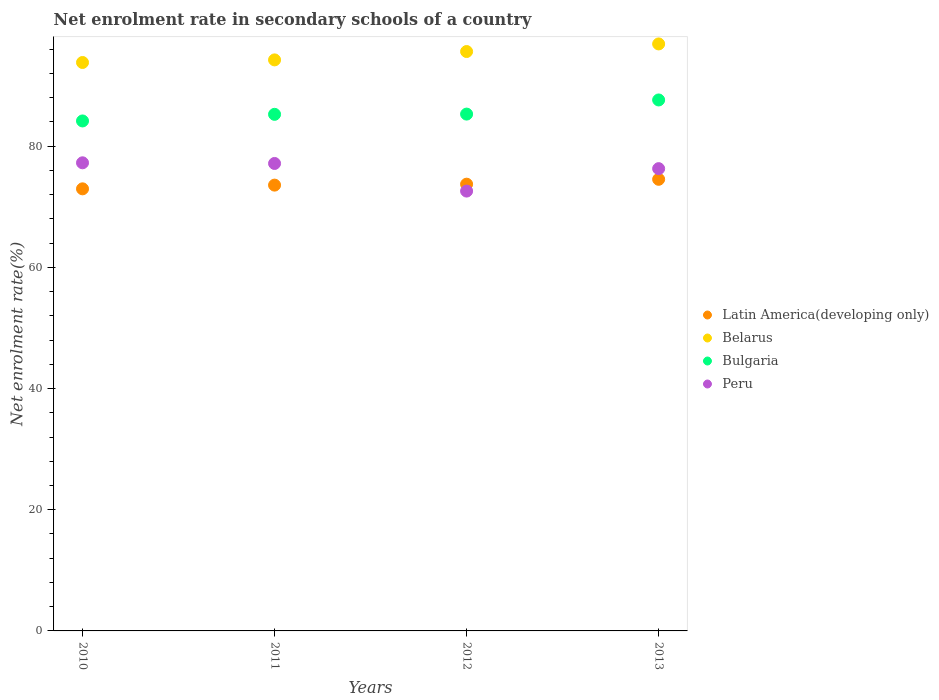How many different coloured dotlines are there?
Make the answer very short. 4. What is the net enrolment rate in secondary schools in Latin America(developing only) in 2012?
Give a very brief answer. 73.72. Across all years, what is the maximum net enrolment rate in secondary schools in Belarus?
Offer a very short reply. 96.86. Across all years, what is the minimum net enrolment rate in secondary schools in Bulgaria?
Keep it short and to the point. 84.15. In which year was the net enrolment rate in secondary schools in Bulgaria maximum?
Offer a very short reply. 2013. In which year was the net enrolment rate in secondary schools in Peru minimum?
Your answer should be compact. 2012. What is the total net enrolment rate in secondary schools in Latin America(developing only) in the graph?
Offer a terse response. 294.76. What is the difference between the net enrolment rate in secondary schools in Bulgaria in 2010 and that in 2013?
Your answer should be compact. -3.46. What is the difference between the net enrolment rate in secondary schools in Bulgaria in 2013 and the net enrolment rate in secondary schools in Latin America(developing only) in 2012?
Offer a very short reply. 13.9. What is the average net enrolment rate in secondary schools in Peru per year?
Your answer should be compact. 75.81. In the year 2012, what is the difference between the net enrolment rate in secondary schools in Belarus and net enrolment rate in secondary schools in Latin America(developing only)?
Provide a succinct answer. 21.89. In how many years, is the net enrolment rate in secondary schools in Peru greater than 44 %?
Make the answer very short. 4. What is the ratio of the net enrolment rate in secondary schools in Latin America(developing only) in 2011 to that in 2013?
Provide a short and direct response. 0.99. Is the difference between the net enrolment rate in secondary schools in Belarus in 2010 and 2012 greater than the difference between the net enrolment rate in secondary schools in Latin America(developing only) in 2010 and 2012?
Provide a succinct answer. No. What is the difference between the highest and the second highest net enrolment rate in secondary schools in Belarus?
Ensure brevity in your answer.  1.25. What is the difference between the highest and the lowest net enrolment rate in secondary schools in Latin America(developing only)?
Provide a succinct answer. 1.57. Is the sum of the net enrolment rate in secondary schools in Belarus in 2010 and 2013 greater than the maximum net enrolment rate in secondary schools in Bulgaria across all years?
Your answer should be compact. Yes. Is it the case that in every year, the sum of the net enrolment rate in secondary schools in Belarus and net enrolment rate in secondary schools in Bulgaria  is greater than the sum of net enrolment rate in secondary schools in Latin America(developing only) and net enrolment rate in secondary schools in Peru?
Your answer should be very brief. Yes. Is it the case that in every year, the sum of the net enrolment rate in secondary schools in Belarus and net enrolment rate in secondary schools in Peru  is greater than the net enrolment rate in secondary schools in Latin America(developing only)?
Offer a very short reply. Yes. Does the net enrolment rate in secondary schools in Bulgaria monotonically increase over the years?
Give a very brief answer. Yes. Is the net enrolment rate in secondary schools in Latin America(developing only) strictly greater than the net enrolment rate in secondary schools in Belarus over the years?
Offer a very short reply. No. How many dotlines are there?
Ensure brevity in your answer.  4. Does the graph contain any zero values?
Give a very brief answer. No. Does the graph contain grids?
Provide a short and direct response. No. Where does the legend appear in the graph?
Offer a terse response. Center right. How many legend labels are there?
Offer a terse response. 4. What is the title of the graph?
Offer a very short reply. Net enrolment rate in secondary schools of a country. What is the label or title of the Y-axis?
Offer a terse response. Net enrolment rate(%). What is the Net enrolment rate(%) of Latin America(developing only) in 2010?
Keep it short and to the point. 72.95. What is the Net enrolment rate(%) in Belarus in 2010?
Offer a very short reply. 93.8. What is the Net enrolment rate(%) in Bulgaria in 2010?
Provide a succinct answer. 84.15. What is the Net enrolment rate(%) of Peru in 2010?
Provide a short and direct response. 77.25. What is the Net enrolment rate(%) of Latin America(developing only) in 2011?
Make the answer very short. 73.56. What is the Net enrolment rate(%) of Belarus in 2011?
Provide a succinct answer. 94.23. What is the Net enrolment rate(%) of Bulgaria in 2011?
Ensure brevity in your answer.  85.25. What is the Net enrolment rate(%) in Peru in 2011?
Ensure brevity in your answer.  77.14. What is the Net enrolment rate(%) of Latin America(developing only) in 2012?
Offer a terse response. 73.72. What is the Net enrolment rate(%) in Belarus in 2012?
Offer a very short reply. 95.61. What is the Net enrolment rate(%) in Bulgaria in 2012?
Give a very brief answer. 85.29. What is the Net enrolment rate(%) of Peru in 2012?
Offer a terse response. 72.58. What is the Net enrolment rate(%) in Latin America(developing only) in 2013?
Your answer should be very brief. 74.52. What is the Net enrolment rate(%) of Belarus in 2013?
Keep it short and to the point. 96.86. What is the Net enrolment rate(%) in Bulgaria in 2013?
Offer a very short reply. 87.62. What is the Net enrolment rate(%) in Peru in 2013?
Offer a very short reply. 76.28. Across all years, what is the maximum Net enrolment rate(%) of Latin America(developing only)?
Give a very brief answer. 74.52. Across all years, what is the maximum Net enrolment rate(%) in Belarus?
Your answer should be compact. 96.86. Across all years, what is the maximum Net enrolment rate(%) in Bulgaria?
Offer a very short reply. 87.62. Across all years, what is the maximum Net enrolment rate(%) of Peru?
Your answer should be compact. 77.25. Across all years, what is the minimum Net enrolment rate(%) in Latin America(developing only)?
Ensure brevity in your answer.  72.95. Across all years, what is the minimum Net enrolment rate(%) of Belarus?
Make the answer very short. 93.8. Across all years, what is the minimum Net enrolment rate(%) of Bulgaria?
Offer a terse response. 84.15. Across all years, what is the minimum Net enrolment rate(%) in Peru?
Offer a terse response. 72.58. What is the total Net enrolment rate(%) in Latin America(developing only) in the graph?
Your answer should be compact. 294.76. What is the total Net enrolment rate(%) of Belarus in the graph?
Your response must be concise. 380.5. What is the total Net enrolment rate(%) of Bulgaria in the graph?
Provide a short and direct response. 342.3. What is the total Net enrolment rate(%) of Peru in the graph?
Your answer should be very brief. 303.25. What is the difference between the Net enrolment rate(%) in Latin America(developing only) in 2010 and that in 2011?
Keep it short and to the point. -0.61. What is the difference between the Net enrolment rate(%) in Belarus in 2010 and that in 2011?
Offer a very short reply. -0.43. What is the difference between the Net enrolment rate(%) of Bulgaria in 2010 and that in 2011?
Offer a terse response. -1.09. What is the difference between the Net enrolment rate(%) of Peru in 2010 and that in 2011?
Your answer should be very brief. 0.11. What is the difference between the Net enrolment rate(%) in Latin America(developing only) in 2010 and that in 2012?
Make the answer very short. -0.77. What is the difference between the Net enrolment rate(%) in Belarus in 2010 and that in 2012?
Make the answer very short. -1.81. What is the difference between the Net enrolment rate(%) in Bulgaria in 2010 and that in 2012?
Your answer should be very brief. -1.13. What is the difference between the Net enrolment rate(%) in Peru in 2010 and that in 2012?
Your response must be concise. 4.67. What is the difference between the Net enrolment rate(%) in Latin America(developing only) in 2010 and that in 2013?
Offer a terse response. -1.57. What is the difference between the Net enrolment rate(%) of Belarus in 2010 and that in 2013?
Your response must be concise. -3.06. What is the difference between the Net enrolment rate(%) in Bulgaria in 2010 and that in 2013?
Offer a terse response. -3.46. What is the difference between the Net enrolment rate(%) in Peru in 2010 and that in 2013?
Offer a very short reply. 0.96. What is the difference between the Net enrolment rate(%) of Latin America(developing only) in 2011 and that in 2012?
Provide a short and direct response. -0.16. What is the difference between the Net enrolment rate(%) of Belarus in 2011 and that in 2012?
Your answer should be compact. -1.38. What is the difference between the Net enrolment rate(%) of Bulgaria in 2011 and that in 2012?
Provide a short and direct response. -0.04. What is the difference between the Net enrolment rate(%) of Peru in 2011 and that in 2012?
Offer a very short reply. 4.56. What is the difference between the Net enrolment rate(%) in Latin America(developing only) in 2011 and that in 2013?
Offer a very short reply. -0.96. What is the difference between the Net enrolment rate(%) of Belarus in 2011 and that in 2013?
Offer a terse response. -2.63. What is the difference between the Net enrolment rate(%) in Bulgaria in 2011 and that in 2013?
Provide a succinct answer. -2.37. What is the difference between the Net enrolment rate(%) in Peru in 2011 and that in 2013?
Your answer should be very brief. 0.86. What is the difference between the Net enrolment rate(%) in Latin America(developing only) in 2012 and that in 2013?
Provide a short and direct response. -0.8. What is the difference between the Net enrolment rate(%) in Belarus in 2012 and that in 2013?
Your answer should be compact. -1.25. What is the difference between the Net enrolment rate(%) of Bulgaria in 2012 and that in 2013?
Provide a succinct answer. -2.33. What is the difference between the Net enrolment rate(%) of Peru in 2012 and that in 2013?
Your answer should be compact. -3.7. What is the difference between the Net enrolment rate(%) of Latin America(developing only) in 2010 and the Net enrolment rate(%) of Belarus in 2011?
Your answer should be compact. -21.28. What is the difference between the Net enrolment rate(%) of Latin America(developing only) in 2010 and the Net enrolment rate(%) of Bulgaria in 2011?
Your answer should be compact. -12.29. What is the difference between the Net enrolment rate(%) in Latin America(developing only) in 2010 and the Net enrolment rate(%) in Peru in 2011?
Provide a short and direct response. -4.19. What is the difference between the Net enrolment rate(%) of Belarus in 2010 and the Net enrolment rate(%) of Bulgaria in 2011?
Offer a terse response. 8.55. What is the difference between the Net enrolment rate(%) in Belarus in 2010 and the Net enrolment rate(%) in Peru in 2011?
Give a very brief answer. 16.66. What is the difference between the Net enrolment rate(%) in Bulgaria in 2010 and the Net enrolment rate(%) in Peru in 2011?
Provide a succinct answer. 7.02. What is the difference between the Net enrolment rate(%) in Latin America(developing only) in 2010 and the Net enrolment rate(%) in Belarus in 2012?
Your answer should be very brief. -22.66. What is the difference between the Net enrolment rate(%) of Latin America(developing only) in 2010 and the Net enrolment rate(%) of Bulgaria in 2012?
Keep it short and to the point. -12.33. What is the difference between the Net enrolment rate(%) in Latin America(developing only) in 2010 and the Net enrolment rate(%) in Peru in 2012?
Keep it short and to the point. 0.37. What is the difference between the Net enrolment rate(%) of Belarus in 2010 and the Net enrolment rate(%) of Bulgaria in 2012?
Offer a very short reply. 8.51. What is the difference between the Net enrolment rate(%) of Belarus in 2010 and the Net enrolment rate(%) of Peru in 2012?
Your response must be concise. 21.22. What is the difference between the Net enrolment rate(%) of Bulgaria in 2010 and the Net enrolment rate(%) of Peru in 2012?
Your answer should be compact. 11.57. What is the difference between the Net enrolment rate(%) in Latin America(developing only) in 2010 and the Net enrolment rate(%) in Belarus in 2013?
Make the answer very short. -23.91. What is the difference between the Net enrolment rate(%) of Latin America(developing only) in 2010 and the Net enrolment rate(%) of Bulgaria in 2013?
Offer a terse response. -14.67. What is the difference between the Net enrolment rate(%) in Latin America(developing only) in 2010 and the Net enrolment rate(%) in Peru in 2013?
Provide a succinct answer. -3.33. What is the difference between the Net enrolment rate(%) in Belarus in 2010 and the Net enrolment rate(%) in Bulgaria in 2013?
Your answer should be very brief. 6.18. What is the difference between the Net enrolment rate(%) of Belarus in 2010 and the Net enrolment rate(%) of Peru in 2013?
Make the answer very short. 17.52. What is the difference between the Net enrolment rate(%) of Bulgaria in 2010 and the Net enrolment rate(%) of Peru in 2013?
Give a very brief answer. 7.87. What is the difference between the Net enrolment rate(%) in Latin America(developing only) in 2011 and the Net enrolment rate(%) in Belarus in 2012?
Provide a short and direct response. -22.04. What is the difference between the Net enrolment rate(%) in Latin America(developing only) in 2011 and the Net enrolment rate(%) in Bulgaria in 2012?
Your answer should be very brief. -11.72. What is the difference between the Net enrolment rate(%) of Latin America(developing only) in 2011 and the Net enrolment rate(%) of Peru in 2012?
Keep it short and to the point. 0.98. What is the difference between the Net enrolment rate(%) in Belarus in 2011 and the Net enrolment rate(%) in Bulgaria in 2012?
Offer a very short reply. 8.94. What is the difference between the Net enrolment rate(%) of Belarus in 2011 and the Net enrolment rate(%) of Peru in 2012?
Provide a short and direct response. 21.65. What is the difference between the Net enrolment rate(%) of Bulgaria in 2011 and the Net enrolment rate(%) of Peru in 2012?
Give a very brief answer. 12.66. What is the difference between the Net enrolment rate(%) of Latin America(developing only) in 2011 and the Net enrolment rate(%) of Belarus in 2013?
Provide a short and direct response. -23.3. What is the difference between the Net enrolment rate(%) in Latin America(developing only) in 2011 and the Net enrolment rate(%) in Bulgaria in 2013?
Provide a short and direct response. -14.05. What is the difference between the Net enrolment rate(%) in Latin America(developing only) in 2011 and the Net enrolment rate(%) in Peru in 2013?
Keep it short and to the point. -2.72. What is the difference between the Net enrolment rate(%) in Belarus in 2011 and the Net enrolment rate(%) in Bulgaria in 2013?
Make the answer very short. 6.61. What is the difference between the Net enrolment rate(%) in Belarus in 2011 and the Net enrolment rate(%) in Peru in 2013?
Make the answer very short. 17.95. What is the difference between the Net enrolment rate(%) in Bulgaria in 2011 and the Net enrolment rate(%) in Peru in 2013?
Your answer should be very brief. 8.96. What is the difference between the Net enrolment rate(%) in Latin America(developing only) in 2012 and the Net enrolment rate(%) in Belarus in 2013?
Offer a terse response. -23.14. What is the difference between the Net enrolment rate(%) of Latin America(developing only) in 2012 and the Net enrolment rate(%) of Bulgaria in 2013?
Your answer should be compact. -13.9. What is the difference between the Net enrolment rate(%) in Latin America(developing only) in 2012 and the Net enrolment rate(%) in Peru in 2013?
Keep it short and to the point. -2.56. What is the difference between the Net enrolment rate(%) in Belarus in 2012 and the Net enrolment rate(%) in Bulgaria in 2013?
Your answer should be compact. 7.99. What is the difference between the Net enrolment rate(%) in Belarus in 2012 and the Net enrolment rate(%) in Peru in 2013?
Provide a short and direct response. 19.33. What is the difference between the Net enrolment rate(%) of Bulgaria in 2012 and the Net enrolment rate(%) of Peru in 2013?
Your answer should be very brief. 9. What is the average Net enrolment rate(%) of Latin America(developing only) per year?
Ensure brevity in your answer.  73.69. What is the average Net enrolment rate(%) of Belarus per year?
Ensure brevity in your answer.  95.13. What is the average Net enrolment rate(%) in Bulgaria per year?
Ensure brevity in your answer.  85.58. What is the average Net enrolment rate(%) in Peru per year?
Ensure brevity in your answer.  75.81. In the year 2010, what is the difference between the Net enrolment rate(%) in Latin America(developing only) and Net enrolment rate(%) in Belarus?
Your response must be concise. -20.85. In the year 2010, what is the difference between the Net enrolment rate(%) of Latin America(developing only) and Net enrolment rate(%) of Bulgaria?
Provide a succinct answer. -11.2. In the year 2010, what is the difference between the Net enrolment rate(%) in Latin America(developing only) and Net enrolment rate(%) in Peru?
Offer a terse response. -4.3. In the year 2010, what is the difference between the Net enrolment rate(%) in Belarus and Net enrolment rate(%) in Bulgaria?
Offer a terse response. 9.65. In the year 2010, what is the difference between the Net enrolment rate(%) of Belarus and Net enrolment rate(%) of Peru?
Keep it short and to the point. 16.55. In the year 2010, what is the difference between the Net enrolment rate(%) of Bulgaria and Net enrolment rate(%) of Peru?
Make the answer very short. 6.91. In the year 2011, what is the difference between the Net enrolment rate(%) in Latin America(developing only) and Net enrolment rate(%) in Belarus?
Provide a short and direct response. -20.66. In the year 2011, what is the difference between the Net enrolment rate(%) of Latin America(developing only) and Net enrolment rate(%) of Bulgaria?
Offer a terse response. -11.68. In the year 2011, what is the difference between the Net enrolment rate(%) in Latin America(developing only) and Net enrolment rate(%) in Peru?
Keep it short and to the point. -3.57. In the year 2011, what is the difference between the Net enrolment rate(%) in Belarus and Net enrolment rate(%) in Bulgaria?
Provide a short and direct response. 8.98. In the year 2011, what is the difference between the Net enrolment rate(%) of Belarus and Net enrolment rate(%) of Peru?
Your answer should be compact. 17.09. In the year 2011, what is the difference between the Net enrolment rate(%) of Bulgaria and Net enrolment rate(%) of Peru?
Make the answer very short. 8.11. In the year 2012, what is the difference between the Net enrolment rate(%) in Latin America(developing only) and Net enrolment rate(%) in Belarus?
Your answer should be very brief. -21.89. In the year 2012, what is the difference between the Net enrolment rate(%) of Latin America(developing only) and Net enrolment rate(%) of Bulgaria?
Make the answer very short. -11.57. In the year 2012, what is the difference between the Net enrolment rate(%) of Latin America(developing only) and Net enrolment rate(%) of Peru?
Your response must be concise. 1.14. In the year 2012, what is the difference between the Net enrolment rate(%) of Belarus and Net enrolment rate(%) of Bulgaria?
Provide a short and direct response. 10.32. In the year 2012, what is the difference between the Net enrolment rate(%) of Belarus and Net enrolment rate(%) of Peru?
Provide a succinct answer. 23.03. In the year 2012, what is the difference between the Net enrolment rate(%) in Bulgaria and Net enrolment rate(%) in Peru?
Offer a very short reply. 12.7. In the year 2013, what is the difference between the Net enrolment rate(%) in Latin America(developing only) and Net enrolment rate(%) in Belarus?
Ensure brevity in your answer.  -22.34. In the year 2013, what is the difference between the Net enrolment rate(%) in Latin America(developing only) and Net enrolment rate(%) in Bulgaria?
Provide a succinct answer. -13.09. In the year 2013, what is the difference between the Net enrolment rate(%) in Latin America(developing only) and Net enrolment rate(%) in Peru?
Ensure brevity in your answer.  -1.76. In the year 2013, what is the difference between the Net enrolment rate(%) in Belarus and Net enrolment rate(%) in Bulgaria?
Offer a very short reply. 9.25. In the year 2013, what is the difference between the Net enrolment rate(%) in Belarus and Net enrolment rate(%) in Peru?
Give a very brief answer. 20.58. In the year 2013, what is the difference between the Net enrolment rate(%) in Bulgaria and Net enrolment rate(%) in Peru?
Offer a very short reply. 11.34. What is the ratio of the Net enrolment rate(%) in Latin America(developing only) in 2010 to that in 2011?
Give a very brief answer. 0.99. What is the ratio of the Net enrolment rate(%) in Bulgaria in 2010 to that in 2011?
Ensure brevity in your answer.  0.99. What is the ratio of the Net enrolment rate(%) in Peru in 2010 to that in 2011?
Give a very brief answer. 1. What is the ratio of the Net enrolment rate(%) in Belarus in 2010 to that in 2012?
Provide a succinct answer. 0.98. What is the ratio of the Net enrolment rate(%) in Bulgaria in 2010 to that in 2012?
Ensure brevity in your answer.  0.99. What is the ratio of the Net enrolment rate(%) in Peru in 2010 to that in 2012?
Offer a very short reply. 1.06. What is the ratio of the Net enrolment rate(%) in Latin America(developing only) in 2010 to that in 2013?
Your response must be concise. 0.98. What is the ratio of the Net enrolment rate(%) in Belarus in 2010 to that in 2013?
Provide a short and direct response. 0.97. What is the ratio of the Net enrolment rate(%) of Bulgaria in 2010 to that in 2013?
Provide a succinct answer. 0.96. What is the ratio of the Net enrolment rate(%) in Peru in 2010 to that in 2013?
Keep it short and to the point. 1.01. What is the ratio of the Net enrolment rate(%) in Latin America(developing only) in 2011 to that in 2012?
Keep it short and to the point. 1. What is the ratio of the Net enrolment rate(%) in Belarus in 2011 to that in 2012?
Your answer should be very brief. 0.99. What is the ratio of the Net enrolment rate(%) of Bulgaria in 2011 to that in 2012?
Your response must be concise. 1. What is the ratio of the Net enrolment rate(%) of Peru in 2011 to that in 2012?
Your response must be concise. 1.06. What is the ratio of the Net enrolment rate(%) in Latin America(developing only) in 2011 to that in 2013?
Provide a short and direct response. 0.99. What is the ratio of the Net enrolment rate(%) in Belarus in 2011 to that in 2013?
Ensure brevity in your answer.  0.97. What is the ratio of the Net enrolment rate(%) of Bulgaria in 2011 to that in 2013?
Your response must be concise. 0.97. What is the ratio of the Net enrolment rate(%) in Peru in 2011 to that in 2013?
Keep it short and to the point. 1.01. What is the ratio of the Net enrolment rate(%) in Latin America(developing only) in 2012 to that in 2013?
Give a very brief answer. 0.99. What is the ratio of the Net enrolment rate(%) of Belarus in 2012 to that in 2013?
Your response must be concise. 0.99. What is the ratio of the Net enrolment rate(%) of Bulgaria in 2012 to that in 2013?
Offer a terse response. 0.97. What is the ratio of the Net enrolment rate(%) in Peru in 2012 to that in 2013?
Provide a succinct answer. 0.95. What is the difference between the highest and the second highest Net enrolment rate(%) in Latin America(developing only)?
Keep it short and to the point. 0.8. What is the difference between the highest and the second highest Net enrolment rate(%) in Belarus?
Offer a terse response. 1.25. What is the difference between the highest and the second highest Net enrolment rate(%) in Bulgaria?
Your response must be concise. 2.33. What is the difference between the highest and the second highest Net enrolment rate(%) in Peru?
Keep it short and to the point. 0.11. What is the difference between the highest and the lowest Net enrolment rate(%) of Latin America(developing only)?
Your answer should be compact. 1.57. What is the difference between the highest and the lowest Net enrolment rate(%) of Belarus?
Offer a terse response. 3.06. What is the difference between the highest and the lowest Net enrolment rate(%) in Bulgaria?
Your answer should be very brief. 3.46. What is the difference between the highest and the lowest Net enrolment rate(%) in Peru?
Offer a very short reply. 4.67. 